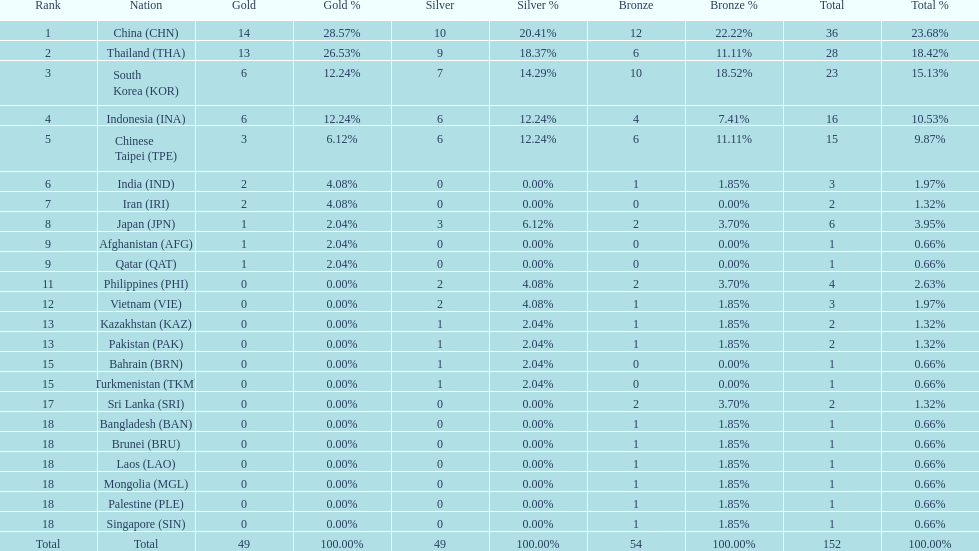Which countries won the same number of gold medals as japan? Afghanistan (AFG), Qatar (QAT). 